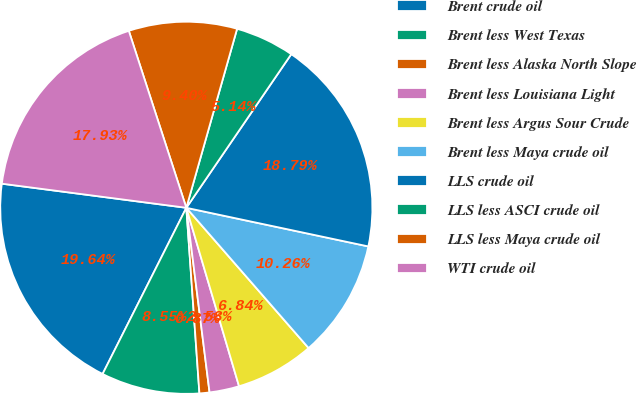Convert chart. <chart><loc_0><loc_0><loc_500><loc_500><pie_chart><fcel>Brent crude oil<fcel>Brent less West Texas<fcel>Brent less Alaska North Slope<fcel>Brent less Louisiana Light<fcel>Brent less Argus Sour Crude<fcel>Brent less Maya crude oil<fcel>LLS crude oil<fcel>LLS less ASCI crude oil<fcel>LLS less Maya crude oil<fcel>WTI crude oil<nl><fcel>19.64%<fcel>8.55%<fcel>0.87%<fcel>2.58%<fcel>6.84%<fcel>10.26%<fcel>18.79%<fcel>5.14%<fcel>9.4%<fcel>17.93%<nl></chart> 